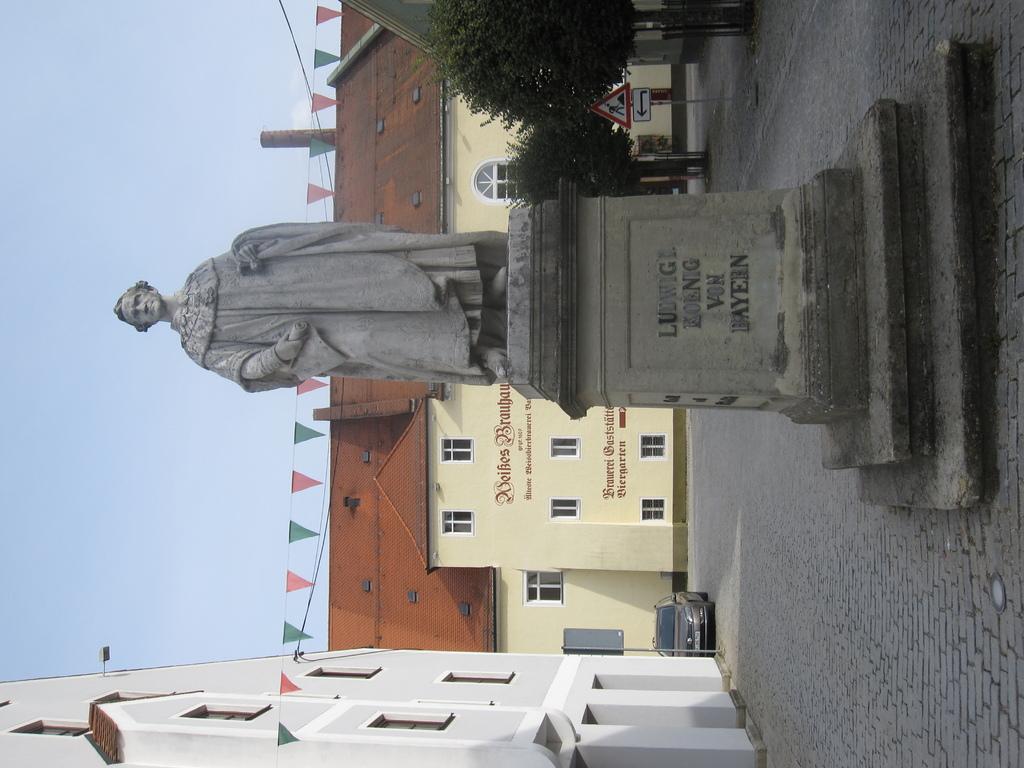What does the statue say?
Your answer should be compact. Ludwig koenig von bayern. 